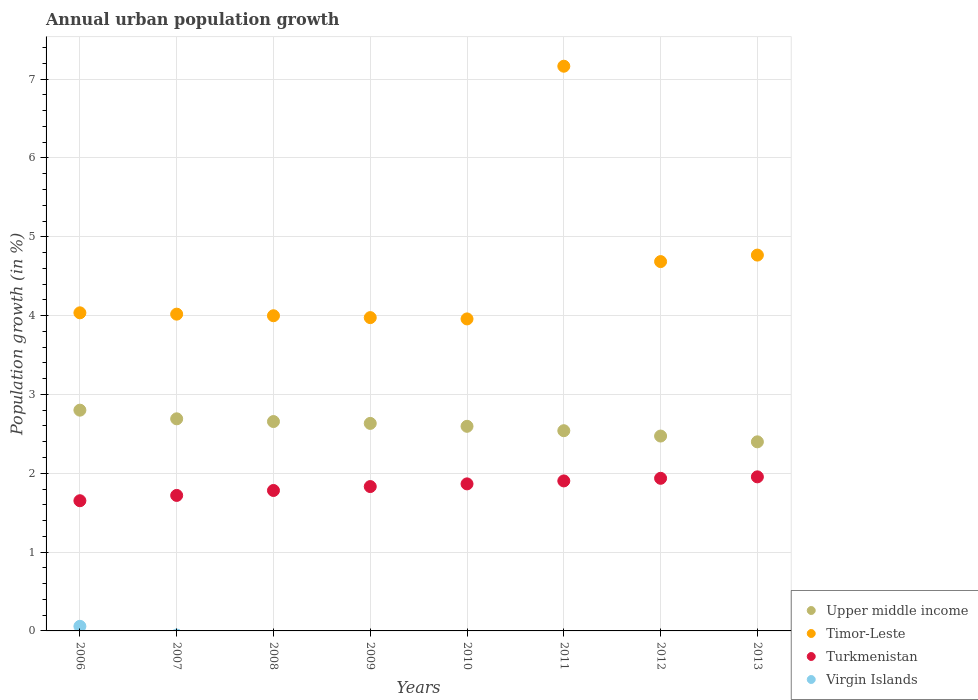How many different coloured dotlines are there?
Ensure brevity in your answer.  4. What is the percentage of urban population growth in Turkmenistan in 2007?
Make the answer very short. 1.72. Across all years, what is the maximum percentage of urban population growth in Upper middle income?
Make the answer very short. 2.8. Across all years, what is the minimum percentage of urban population growth in Upper middle income?
Your answer should be compact. 2.4. In which year was the percentage of urban population growth in Turkmenistan maximum?
Ensure brevity in your answer.  2013. What is the total percentage of urban population growth in Virgin Islands in the graph?
Your response must be concise. 0.06. What is the difference between the percentage of urban population growth in Timor-Leste in 2009 and that in 2011?
Give a very brief answer. -3.19. What is the difference between the percentage of urban population growth in Turkmenistan in 2006 and the percentage of urban population growth in Timor-Leste in 2007?
Your answer should be compact. -2.37. What is the average percentage of urban population growth in Timor-Leste per year?
Your response must be concise. 4.58. In the year 2008, what is the difference between the percentage of urban population growth in Upper middle income and percentage of urban population growth in Turkmenistan?
Your response must be concise. 0.87. What is the ratio of the percentage of urban population growth in Upper middle income in 2006 to that in 2010?
Offer a very short reply. 1.08. Is the percentage of urban population growth in Upper middle income in 2010 less than that in 2011?
Your response must be concise. No. What is the difference between the highest and the second highest percentage of urban population growth in Turkmenistan?
Give a very brief answer. 0.02. What is the difference between the highest and the lowest percentage of urban population growth in Virgin Islands?
Provide a succinct answer. 0.06. Is the sum of the percentage of urban population growth in Timor-Leste in 2006 and 2010 greater than the maximum percentage of urban population growth in Turkmenistan across all years?
Provide a short and direct response. Yes. Is it the case that in every year, the sum of the percentage of urban population growth in Upper middle income and percentage of urban population growth in Timor-Leste  is greater than the sum of percentage of urban population growth in Virgin Islands and percentage of urban population growth in Turkmenistan?
Your answer should be compact. Yes. Is it the case that in every year, the sum of the percentage of urban population growth in Turkmenistan and percentage of urban population growth in Virgin Islands  is greater than the percentage of urban population growth in Timor-Leste?
Offer a terse response. No. Does the percentage of urban population growth in Upper middle income monotonically increase over the years?
Your response must be concise. No. Is the percentage of urban population growth in Timor-Leste strictly less than the percentage of urban population growth in Upper middle income over the years?
Offer a terse response. No. How many dotlines are there?
Give a very brief answer. 4. Are the values on the major ticks of Y-axis written in scientific E-notation?
Make the answer very short. No. Does the graph contain any zero values?
Ensure brevity in your answer.  Yes. Does the graph contain grids?
Ensure brevity in your answer.  Yes. Where does the legend appear in the graph?
Your answer should be compact. Bottom right. How many legend labels are there?
Your answer should be very brief. 4. How are the legend labels stacked?
Provide a succinct answer. Vertical. What is the title of the graph?
Make the answer very short. Annual urban population growth. Does "Tanzania" appear as one of the legend labels in the graph?
Make the answer very short. No. What is the label or title of the X-axis?
Provide a short and direct response. Years. What is the label or title of the Y-axis?
Offer a terse response. Population growth (in %). What is the Population growth (in %) in Upper middle income in 2006?
Your response must be concise. 2.8. What is the Population growth (in %) in Timor-Leste in 2006?
Make the answer very short. 4.04. What is the Population growth (in %) of Turkmenistan in 2006?
Give a very brief answer. 1.65. What is the Population growth (in %) in Virgin Islands in 2006?
Offer a very short reply. 0.06. What is the Population growth (in %) of Upper middle income in 2007?
Make the answer very short. 2.69. What is the Population growth (in %) of Timor-Leste in 2007?
Give a very brief answer. 4.02. What is the Population growth (in %) in Turkmenistan in 2007?
Offer a terse response. 1.72. What is the Population growth (in %) in Virgin Islands in 2007?
Give a very brief answer. 0. What is the Population growth (in %) of Upper middle income in 2008?
Keep it short and to the point. 2.66. What is the Population growth (in %) of Timor-Leste in 2008?
Ensure brevity in your answer.  4. What is the Population growth (in %) of Turkmenistan in 2008?
Keep it short and to the point. 1.78. What is the Population growth (in %) in Virgin Islands in 2008?
Your answer should be compact. 0. What is the Population growth (in %) in Upper middle income in 2009?
Your response must be concise. 2.63. What is the Population growth (in %) of Timor-Leste in 2009?
Give a very brief answer. 3.97. What is the Population growth (in %) in Turkmenistan in 2009?
Provide a short and direct response. 1.83. What is the Population growth (in %) in Upper middle income in 2010?
Offer a terse response. 2.6. What is the Population growth (in %) of Timor-Leste in 2010?
Provide a succinct answer. 3.96. What is the Population growth (in %) in Turkmenistan in 2010?
Your answer should be very brief. 1.87. What is the Population growth (in %) in Upper middle income in 2011?
Provide a succinct answer. 2.54. What is the Population growth (in %) in Timor-Leste in 2011?
Offer a very short reply. 7.16. What is the Population growth (in %) of Turkmenistan in 2011?
Your answer should be compact. 1.9. What is the Population growth (in %) of Virgin Islands in 2011?
Keep it short and to the point. 0. What is the Population growth (in %) of Upper middle income in 2012?
Your answer should be very brief. 2.47. What is the Population growth (in %) in Timor-Leste in 2012?
Offer a very short reply. 4.69. What is the Population growth (in %) in Turkmenistan in 2012?
Your answer should be very brief. 1.94. What is the Population growth (in %) of Virgin Islands in 2012?
Offer a terse response. 0. What is the Population growth (in %) in Upper middle income in 2013?
Ensure brevity in your answer.  2.4. What is the Population growth (in %) of Timor-Leste in 2013?
Offer a terse response. 4.77. What is the Population growth (in %) in Turkmenistan in 2013?
Ensure brevity in your answer.  1.95. Across all years, what is the maximum Population growth (in %) in Upper middle income?
Offer a terse response. 2.8. Across all years, what is the maximum Population growth (in %) in Timor-Leste?
Provide a short and direct response. 7.16. Across all years, what is the maximum Population growth (in %) of Turkmenistan?
Give a very brief answer. 1.95. Across all years, what is the maximum Population growth (in %) of Virgin Islands?
Make the answer very short. 0.06. Across all years, what is the minimum Population growth (in %) in Upper middle income?
Provide a short and direct response. 2.4. Across all years, what is the minimum Population growth (in %) of Timor-Leste?
Give a very brief answer. 3.96. Across all years, what is the minimum Population growth (in %) in Turkmenistan?
Ensure brevity in your answer.  1.65. Across all years, what is the minimum Population growth (in %) of Virgin Islands?
Give a very brief answer. 0. What is the total Population growth (in %) in Upper middle income in the graph?
Ensure brevity in your answer.  20.79. What is the total Population growth (in %) in Timor-Leste in the graph?
Make the answer very short. 36.6. What is the total Population growth (in %) in Turkmenistan in the graph?
Offer a terse response. 14.64. What is the total Population growth (in %) in Virgin Islands in the graph?
Provide a short and direct response. 0.06. What is the difference between the Population growth (in %) of Upper middle income in 2006 and that in 2007?
Give a very brief answer. 0.11. What is the difference between the Population growth (in %) in Timor-Leste in 2006 and that in 2007?
Offer a terse response. 0.02. What is the difference between the Population growth (in %) of Turkmenistan in 2006 and that in 2007?
Offer a terse response. -0.07. What is the difference between the Population growth (in %) in Upper middle income in 2006 and that in 2008?
Your answer should be very brief. 0.14. What is the difference between the Population growth (in %) in Timor-Leste in 2006 and that in 2008?
Provide a short and direct response. 0.04. What is the difference between the Population growth (in %) of Turkmenistan in 2006 and that in 2008?
Give a very brief answer. -0.13. What is the difference between the Population growth (in %) in Upper middle income in 2006 and that in 2009?
Your answer should be compact. 0.17. What is the difference between the Population growth (in %) of Timor-Leste in 2006 and that in 2009?
Your answer should be very brief. 0.06. What is the difference between the Population growth (in %) of Turkmenistan in 2006 and that in 2009?
Provide a short and direct response. -0.18. What is the difference between the Population growth (in %) in Upper middle income in 2006 and that in 2010?
Your answer should be compact. 0.2. What is the difference between the Population growth (in %) of Timor-Leste in 2006 and that in 2010?
Offer a terse response. 0.08. What is the difference between the Population growth (in %) of Turkmenistan in 2006 and that in 2010?
Offer a very short reply. -0.21. What is the difference between the Population growth (in %) in Upper middle income in 2006 and that in 2011?
Ensure brevity in your answer.  0.26. What is the difference between the Population growth (in %) in Timor-Leste in 2006 and that in 2011?
Make the answer very short. -3.13. What is the difference between the Population growth (in %) in Turkmenistan in 2006 and that in 2011?
Make the answer very short. -0.25. What is the difference between the Population growth (in %) of Upper middle income in 2006 and that in 2012?
Provide a succinct answer. 0.33. What is the difference between the Population growth (in %) of Timor-Leste in 2006 and that in 2012?
Offer a very short reply. -0.65. What is the difference between the Population growth (in %) of Turkmenistan in 2006 and that in 2012?
Ensure brevity in your answer.  -0.28. What is the difference between the Population growth (in %) of Upper middle income in 2006 and that in 2013?
Offer a very short reply. 0.4. What is the difference between the Population growth (in %) in Timor-Leste in 2006 and that in 2013?
Keep it short and to the point. -0.73. What is the difference between the Population growth (in %) of Turkmenistan in 2006 and that in 2013?
Give a very brief answer. -0.3. What is the difference between the Population growth (in %) in Upper middle income in 2007 and that in 2008?
Your answer should be compact. 0.03. What is the difference between the Population growth (in %) of Timor-Leste in 2007 and that in 2008?
Keep it short and to the point. 0.02. What is the difference between the Population growth (in %) in Turkmenistan in 2007 and that in 2008?
Keep it short and to the point. -0.06. What is the difference between the Population growth (in %) in Upper middle income in 2007 and that in 2009?
Ensure brevity in your answer.  0.06. What is the difference between the Population growth (in %) in Timor-Leste in 2007 and that in 2009?
Provide a succinct answer. 0.04. What is the difference between the Population growth (in %) in Turkmenistan in 2007 and that in 2009?
Your answer should be compact. -0.11. What is the difference between the Population growth (in %) in Upper middle income in 2007 and that in 2010?
Make the answer very short. 0.1. What is the difference between the Population growth (in %) in Timor-Leste in 2007 and that in 2010?
Offer a terse response. 0.06. What is the difference between the Population growth (in %) in Turkmenistan in 2007 and that in 2010?
Give a very brief answer. -0.15. What is the difference between the Population growth (in %) in Upper middle income in 2007 and that in 2011?
Your answer should be very brief. 0.15. What is the difference between the Population growth (in %) in Timor-Leste in 2007 and that in 2011?
Provide a short and direct response. -3.15. What is the difference between the Population growth (in %) in Turkmenistan in 2007 and that in 2011?
Provide a short and direct response. -0.18. What is the difference between the Population growth (in %) in Upper middle income in 2007 and that in 2012?
Provide a succinct answer. 0.22. What is the difference between the Population growth (in %) of Timor-Leste in 2007 and that in 2012?
Give a very brief answer. -0.67. What is the difference between the Population growth (in %) in Turkmenistan in 2007 and that in 2012?
Your response must be concise. -0.22. What is the difference between the Population growth (in %) in Upper middle income in 2007 and that in 2013?
Your answer should be very brief. 0.29. What is the difference between the Population growth (in %) of Timor-Leste in 2007 and that in 2013?
Offer a terse response. -0.75. What is the difference between the Population growth (in %) in Turkmenistan in 2007 and that in 2013?
Keep it short and to the point. -0.24. What is the difference between the Population growth (in %) in Upper middle income in 2008 and that in 2009?
Offer a terse response. 0.02. What is the difference between the Population growth (in %) in Timor-Leste in 2008 and that in 2009?
Offer a terse response. 0.02. What is the difference between the Population growth (in %) of Turkmenistan in 2008 and that in 2009?
Provide a short and direct response. -0.05. What is the difference between the Population growth (in %) in Upper middle income in 2008 and that in 2010?
Offer a terse response. 0.06. What is the difference between the Population growth (in %) of Timor-Leste in 2008 and that in 2010?
Your response must be concise. 0.04. What is the difference between the Population growth (in %) of Turkmenistan in 2008 and that in 2010?
Ensure brevity in your answer.  -0.08. What is the difference between the Population growth (in %) of Upper middle income in 2008 and that in 2011?
Make the answer very short. 0.12. What is the difference between the Population growth (in %) of Timor-Leste in 2008 and that in 2011?
Offer a very short reply. -3.17. What is the difference between the Population growth (in %) of Turkmenistan in 2008 and that in 2011?
Make the answer very short. -0.12. What is the difference between the Population growth (in %) of Upper middle income in 2008 and that in 2012?
Make the answer very short. 0.18. What is the difference between the Population growth (in %) of Timor-Leste in 2008 and that in 2012?
Offer a terse response. -0.69. What is the difference between the Population growth (in %) in Turkmenistan in 2008 and that in 2012?
Give a very brief answer. -0.15. What is the difference between the Population growth (in %) of Upper middle income in 2008 and that in 2013?
Offer a very short reply. 0.26. What is the difference between the Population growth (in %) in Timor-Leste in 2008 and that in 2013?
Make the answer very short. -0.77. What is the difference between the Population growth (in %) in Turkmenistan in 2008 and that in 2013?
Your answer should be very brief. -0.17. What is the difference between the Population growth (in %) of Upper middle income in 2009 and that in 2010?
Your answer should be very brief. 0.04. What is the difference between the Population growth (in %) of Timor-Leste in 2009 and that in 2010?
Your answer should be very brief. 0.02. What is the difference between the Population growth (in %) in Turkmenistan in 2009 and that in 2010?
Provide a succinct answer. -0.03. What is the difference between the Population growth (in %) of Upper middle income in 2009 and that in 2011?
Provide a succinct answer. 0.09. What is the difference between the Population growth (in %) in Timor-Leste in 2009 and that in 2011?
Provide a succinct answer. -3.19. What is the difference between the Population growth (in %) of Turkmenistan in 2009 and that in 2011?
Your answer should be very brief. -0.07. What is the difference between the Population growth (in %) in Upper middle income in 2009 and that in 2012?
Offer a terse response. 0.16. What is the difference between the Population growth (in %) of Timor-Leste in 2009 and that in 2012?
Your answer should be very brief. -0.71. What is the difference between the Population growth (in %) of Turkmenistan in 2009 and that in 2012?
Make the answer very short. -0.1. What is the difference between the Population growth (in %) in Upper middle income in 2009 and that in 2013?
Keep it short and to the point. 0.23. What is the difference between the Population growth (in %) of Timor-Leste in 2009 and that in 2013?
Keep it short and to the point. -0.79. What is the difference between the Population growth (in %) of Turkmenistan in 2009 and that in 2013?
Give a very brief answer. -0.12. What is the difference between the Population growth (in %) of Upper middle income in 2010 and that in 2011?
Offer a very short reply. 0.06. What is the difference between the Population growth (in %) in Timor-Leste in 2010 and that in 2011?
Provide a short and direct response. -3.21. What is the difference between the Population growth (in %) of Turkmenistan in 2010 and that in 2011?
Your answer should be compact. -0.04. What is the difference between the Population growth (in %) in Upper middle income in 2010 and that in 2012?
Offer a very short reply. 0.12. What is the difference between the Population growth (in %) in Timor-Leste in 2010 and that in 2012?
Your response must be concise. -0.73. What is the difference between the Population growth (in %) of Turkmenistan in 2010 and that in 2012?
Your answer should be very brief. -0.07. What is the difference between the Population growth (in %) in Upper middle income in 2010 and that in 2013?
Give a very brief answer. 0.2. What is the difference between the Population growth (in %) in Timor-Leste in 2010 and that in 2013?
Offer a very short reply. -0.81. What is the difference between the Population growth (in %) of Turkmenistan in 2010 and that in 2013?
Your answer should be very brief. -0.09. What is the difference between the Population growth (in %) in Upper middle income in 2011 and that in 2012?
Provide a short and direct response. 0.07. What is the difference between the Population growth (in %) of Timor-Leste in 2011 and that in 2012?
Your answer should be compact. 2.48. What is the difference between the Population growth (in %) of Turkmenistan in 2011 and that in 2012?
Your answer should be compact. -0.03. What is the difference between the Population growth (in %) of Upper middle income in 2011 and that in 2013?
Offer a terse response. 0.14. What is the difference between the Population growth (in %) of Timor-Leste in 2011 and that in 2013?
Your answer should be very brief. 2.4. What is the difference between the Population growth (in %) in Turkmenistan in 2011 and that in 2013?
Make the answer very short. -0.05. What is the difference between the Population growth (in %) of Upper middle income in 2012 and that in 2013?
Give a very brief answer. 0.07. What is the difference between the Population growth (in %) in Timor-Leste in 2012 and that in 2013?
Provide a short and direct response. -0.08. What is the difference between the Population growth (in %) in Turkmenistan in 2012 and that in 2013?
Keep it short and to the point. -0.02. What is the difference between the Population growth (in %) in Upper middle income in 2006 and the Population growth (in %) in Timor-Leste in 2007?
Give a very brief answer. -1.22. What is the difference between the Population growth (in %) in Upper middle income in 2006 and the Population growth (in %) in Turkmenistan in 2007?
Offer a terse response. 1.08. What is the difference between the Population growth (in %) of Timor-Leste in 2006 and the Population growth (in %) of Turkmenistan in 2007?
Offer a very short reply. 2.32. What is the difference between the Population growth (in %) of Upper middle income in 2006 and the Population growth (in %) of Timor-Leste in 2008?
Keep it short and to the point. -1.2. What is the difference between the Population growth (in %) of Upper middle income in 2006 and the Population growth (in %) of Turkmenistan in 2008?
Provide a succinct answer. 1.02. What is the difference between the Population growth (in %) in Timor-Leste in 2006 and the Population growth (in %) in Turkmenistan in 2008?
Your response must be concise. 2.25. What is the difference between the Population growth (in %) in Upper middle income in 2006 and the Population growth (in %) in Timor-Leste in 2009?
Keep it short and to the point. -1.17. What is the difference between the Population growth (in %) in Upper middle income in 2006 and the Population growth (in %) in Turkmenistan in 2009?
Provide a short and direct response. 0.97. What is the difference between the Population growth (in %) in Timor-Leste in 2006 and the Population growth (in %) in Turkmenistan in 2009?
Keep it short and to the point. 2.2. What is the difference between the Population growth (in %) of Upper middle income in 2006 and the Population growth (in %) of Timor-Leste in 2010?
Offer a terse response. -1.16. What is the difference between the Population growth (in %) in Upper middle income in 2006 and the Population growth (in %) in Turkmenistan in 2010?
Offer a very short reply. 0.94. What is the difference between the Population growth (in %) in Timor-Leste in 2006 and the Population growth (in %) in Turkmenistan in 2010?
Your response must be concise. 2.17. What is the difference between the Population growth (in %) of Upper middle income in 2006 and the Population growth (in %) of Timor-Leste in 2011?
Offer a very short reply. -4.36. What is the difference between the Population growth (in %) in Upper middle income in 2006 and the Population growth (in %) in Turkmenistan in 2011?
Your response must be concise. 0.9. What is the difference between the Population growth (in %) in Timor-Leste in 2006 and the Population growth (in %) in Turkmenistan in 2011?
Your response must be concise. 2.13. What is the difference between the Population growth (in %) of Upper middle income in 2006 and the Population growth (in %) of Timor-Leste in 2012?
Give a very brief answer. -1.88. What is the difference between the Population growth (in %) of Upper middle income in 2006 and the Population growth (in %) of Turkmenistan in 2012?
Your answer should be compact. 0.86. What is the difference between the Population growth (in %) in Timor-Leste in 2006 and the Population growth (in %) in Turkmenistan in 2012?
Offer a terse response. 2.1. What is the difference between the Population growth (in %) of Upper middle income in 2006 and the Population growth (in %) of Timor-Leste in 2013?
Your response must be concise. -1.97. What is the difference between the Population growth (in %) of Upper middle income in 2006 and the Population growth (in %) of Turkmenistan in 2013?
Your response must be concise. 0.85. What is the difference between the Population growth (in %) of Timor-Leste in 2006 and the Population growth (in %) of Turkmenistan in 2013?
Provide a short and direct response. 2.08. What is the difference between the Population growth (in %) of Upper middle income in 2007 and the Population growth (in %) of Timor-Leste in 2008?
Your answer should be very brief. -1.31. What is the difference between the Population growth (in %) of Timor-Leste in 2007 and the Population growth (in %) of Turkmenistan in 2008?
Provide a short and direct response. 2.24. What is the difference between the Population growth (in %) in Upper middle income in 2007 and the Population growth (in %) in Timor-Leste in 2009?
Your answer should be very brief. -1.28. What is the difference between the Population growth (in %) in Upper middle income in 2007 and the Population growth (in %) in Turkmenistan in 2009?
Your answer should be compact. 0.86. What is the difference between the Population growth (in %) of Timor-Leste in 2007 and the Population growth (in %) of Turkmenistan in 2009?
Give a very brief answer. 2.19. What is the difference between the Population growth (in %) of Upper middle income in 2007 and the Population growth (in %) of Timor-Leste in 2010?
Keep it short and to the point. -1.27. What is the difference between the Population growth (in %) of Upper middle income in 2007 and the Population growth (in %) of Turkmenistan in 2010?
Your response must be concise. 0.83. What is the difference between the Population growth (in %) in Timor-Leste in 2007 and the Population growth (in %) in Turkmenistan in 2010?
Your answer should be compact. 2.15. What is the difference between the Population growth (in %) in Upper middle income in 2007 and the Population growth (in %) in Timor-Leste in 2011?
Your answer should be very brief. -4.47. What is the difference between the Population growth (in %) of Upper middle income in 2007 and the Population growth (in %) of Turkmenistan in 2011?
Provide a succinct answer. 0.79. What is the difference between the Population growth (in %) in Timor-Leste in 2007 and the Population growth (in %) in Turkmenistan in 2011?
Provide a succinct answer. 2.12. What is the difference between the Population growth (in %) in Upper middle income in 2007 and the Population growth (in %) in Timor-Leste in 2012?
Your answer should be compact. -1.99. What is the difference between the Population growth (in %) of Upper middle income in 2007 and the Population growth (in %) of Turkmenistan in 2012?
Keep it short and to the point. 0.75. What is the difference between the Population growth (in %) of Timor-Leste in 2007 and the Population growth (in %) of Turkmenistan in 2012?
Offer a terse response. 2.08. What is the difference between the Population growth (in %) of Upper middle income in 2007 and the Population growth (in %) of Timor-Leste in 2013?
Provide a short and direct response. -2.08. What is the difference between the Population growth (in %) of Upper middle income in 2007 and the Population growth (in %) of Turkmenistan in 2013?
Your answer should be very brief. 0.74. What is the difference between the Population growth (in %) in Timor-Leste in 2007 and the Population growth (in %) in Turkmenistan in 2013?
Give a very brief answer. 2.06. What is the difference between the Population growth (in %) of Upper middle income in 2008 and the Population growth (in %) of Timor-Leste in 2009?
Offer a terse response. -1.32. What is the difference between the Population growth (in %) in Upper middle income in 2008 and the Population growth (in %) in Turkmenistan in 2009?
Your answer should be compact. 0.82. What is the difference between the Population growth (in %) in Timor-Leste in 2008 and the Population growth (in %) in Turkmenistan in 2009?
Ensure brevity in your answer.  2.17. What is the difference between the Population growth (in %) of Upper middle income in 2008 and the Population growth (in %) of Timor-Leste in 2010?
Your answer should be very brief. -1.3. What is the difference between the Population growth (in %) of Upper middle income in 2008 and the Population growth (in %) of Turkmenistan in 2010?
Your answer should be very brief. 0.79. What is the difference between the Population growth (in %) in Timor-Leste in 2008 and the Population growth (in %) in Turkmenistan in 2010?
Offer a very short reply. 2.13. What is the difference between the Population growth (in %) of Upper middle income in 2008 and the Population growth (in %) of Timor-Leste in 2011?
Give a very brief answer. -4.51. What is the difference between the Population growth (in %) in Upper middle income in 2008 and the Population growth (in %) in Turkmenistan in 2011?
Your answer should be compact. 0.75. What is the difference between the Population growth (in %) in Timor-Leste in 2008 and the Population growth (in %) in Turkmenistan in 2011?
Keep it short and to the point. 2.1. What is the difference between the Population growth (in %) in Upper middle income in 2008 and the Population growth (in %) in Timor-Leste in 2012?
Offer a very short reply. -2.03. What is the difference between the Population growth (in %) of Upper middle income in 2008 and the Population growth (in %) of Turkmenistan in 2012?
Offer a very short reply. 0.72. What is the difference between the Population growth (in %) of Timor-Leste in 2008 and the Population growth (in %) of Turkmenistan in 2012?
Your answer should be compact. 2.06. What is the difference between the Population growth (in %) in Upper middle income in 2008 and the Population growth (in %) in Timor-Leste in 2013?
Keep it short and to the point. -2.11. What is the difference between the Population growth (in %) of Upper middle income in 2008 and the Population growth (in %) of Turkmenistan in 2013?
Ensure brevity in your answer.  0.7. What is the difference between the Population growth (in %) of Timor-Leste in 2008 and the Population growth (in %) of Turkmenistan in 2013?
Keep it short and to the point. 2.04. What is the difference between the Population growth (in %) in Upper middle income in 2009 and the Population growth (in %) in Timor-Leste in 2010?
Ensure brevity in your answer.  -1.33. What is the difference between the Population growth (in %) of Upper middle income in 2009 and the Population growth (in %) of Turkmenistan in 2010?
Your response must be concise. 0.77. What is the difference between the Population growth (in %) of Timor-Leste in 2009 and the Population growth (in %) of Turkmenistan in 2010?
Make the answer very short. 2.11. What is the difference between the Population growth (in %) of Upper middle income in 2009 and the Population growth (in %) of Timor-Leste in 2011?
Offer a very short reply. -4.53. What is the difference between the Population growth (in %) in Upper middle income in 2009 and the Population growth (in %) in Turkmenistan in 2011?
Provide a succinct answer. 0.73. What is the difference between the Population growth (in %) in Timor-Leste in 2009 and the Population growth (in %) in Turkmenistan in 2011?
Offer a terse response. 2.07. What is the difference between the Population growth (in %) of Upper middle income in 2009 and the Population growth (in %) of Timor-Leste in 2012?
Your answer should be very brief. -2.05. What is the difference between the Population growth (in %) of Upper middle income in 2009 and the Population growth (in %) of Turkmenistan in 2012?
Offer a terse response. 0.7. What is the difference between the Population growth (in %) in Timor-Leste in 2009 and the Population growth (in %) in Turkmenistan in 2012?
Your response must be concise. 2.04. What is the difference between the Population growth (in %) of Upper middle income in 2009 and the Population growth (in %) of Timor-Leste in 2013?
Keep it short and to the point. -2.14. What is the difference between the Population growth (in %) of Upper middle income in 2009 and the Population growth (in %) of Turkmenistan in 2013?
Your response must be concise. 0.68. What is the difference between the Population growth (in %) of Timor-Leste in 2009 and the Population growth (in %) of Turkmenistan in 2013?
Offer a very short reply. 2.02. What is the difference between the Population growth (in %) of Upper middle income in 2010 and the Population growth (in %) of Timor-Leste in 2011?
Give a very brief answer. -4.57. What is the difference between the Population growth (in %) of Upper middle income in 2010 and the Population growth (in %) of Turkmenistan in 2011?
Your answer should be compact. 0.69. What is the difference between the Population growth (in %) in Timor-Leste in 2010 and the Population growth (in %) in Turkmenistan in 2011?
Provide a short and direct response. 2.06. What is the difference between the Population growth (in %) of Upper middle income in 2010 and the Population growth (in %) of Timor-Leste in 2012?
Your answer should be compact. -2.09. What is the difference between the Population growth (in %) in Upper middle income in 2010 and the Population growth (in %) in Turkmenistan in 2012?
Your answer should be very brief. 0.66. What is the difference between the Population growth (in %) in Timor-Leste in 2010 and the Population growth (in %) in Turkmenistan in 2012?
Ensure brevity in your answer.  2.02. What is the difference between the Population growth (in %) of Upper middle income in 2010 and the Population growth (in %) of Timor-Leste in 2013?
Provide a short and direct response. -2.17. What is the difference between the Population growth (in %) of Upper middle income in 2010 and the Population growth (in %) of Turkmenistan in 2013?
Your answer should be very brief. 0.64. What is the difference between the Population growth (in %) in Timor-Leste in 2010 and the Population growth (in %) in Turkmenistan in 2013?
Offer a very short reply. 2. What is the difference between the Population growth (in %) in Upper middle income in 2011 and the Population growth (in %) in Timor-Leste in 2012?
Your answer should be compact. -2.15. What is the difference between the Population growth (in %) in Upper middle income in 2011 and the Population growth (in %) in Turkmenistan in 2012?
Your response must be concise. 0.6. What is the difference between the Population growth (in %) of Timor-Leste in 2011 and the Population growth (in %) of Turkmenistan in 2012?
Your answer should be compact. 5.23. What is the difference between the Population growth (in %) of Upper middle income in 2011 and the Population growth (in %) of Timor-Leste in 2013?
Offer a terse response. -2.23. What is the difference between the Population growth (in %) in Upper middle income in 2011 and the Population growth (in %) in Turkmenistan in 2013?
Keep it short and to the point. 0.59. What is the difference between the Population growth (in %) in Timor-Leste in 2011 and the Population growth (in %) in Turkmenistan in 2013?
Your answer should be compact. 5.21. What is the difference between the Population growth (in %) of Upper middle income in 2012 and the Population growth (in %) of Timor-Leste in 2013?
Offer a very short reply. -2.3. What is the difference between the Population growth (in %) of Upper middle income in 2012 and the Population growth (in %) of Turkmenistan in 2013?
Your answer should be very brief. 0.52. What is the difference between the Population growth (in %) of Timor-Leste in 2012 and the Population growth (in %) of Turkmenistan in 2013?
Offer a terse response. 2.73. What is the average Population growth (in %) of Upper middle income per year?
Offer a very short reply. 2.6. What is the average Population growth (in %) of Timor-Leste per year?
Offer a terse response. 4.58. What is the average Population growth (in %) of Turkmenistan per year?
Ensure brevity in your answer.  1.83. What is the average Population growth (in %) of Virgin Islands per year?
Provide a succinct answer. 0.01. In the year 2006, what is the difference between the Population growth (in %) of Upper middle income and Population growth (in %) of Timor-Leste?
Your answer should be compact. -1.23. In the year 2006, what is the difference between the Population growth (in %) in Upper middle income and Population growth (in %) in Turkmenistan?
Provide a succinct answer. 1.15. In the year 2006, what is the difference between the Population growth (in %) in Upper middle income and Population growth (in %) in Virgin Islands?
Offer a terse response. 2.74. In the year 2006, what is the difference between the Population growth (in %) of Timor-Leste and Population growth (in %) of Turkmenistan?
Offer a very short reply. 2.38. In the year 2006, what is the difference between the Population growth (in %) of Timor-Leste and Population growth (in %) of Virgin Islands?
Offer a very short reply. 3.98. In the year 2006, what is the difference between the Population growth (in %) in Turkmenistan and Population growth (in %) in Virgin Islands?
Provide a succinct answer. 1.59. In the year 2007, what is the difference between the Population growth (in %) in Upper middle income and Population growth (in %) in Timor-Leste?
Provide a succinct answer. -1.33. In the year 2007, what is the difference between the Population growth (in %) of Upper middle income and Population growth (in %) of Turkmenistan?
Offer a terse response. 0.97. In the year 2007, what is the difference between the Population growth (in %) in Timor-Leste and Population growth (in %) in Turkmenistan?
Give a very brief answer. 2.3. In the year 2008, what is the difference between the Population growth (in %) of Upper middle income and Population growth (in %) of Timor-Leste?
Offer a very short reply. -1.34. In the year 2008, what is the difference between the Population growth (in %) in Upper middle income and Population growth (in %) in Turkmenistan?
Provide a short and direct response. 0.87. In the year 2008, what is the difference between the Population growth (in %) of Timor-Leste and Population growth (in %) of Turkmenistan?
Your answer should be very brief. 2.22. In the year 2009, what is the difference between the Population growth (in %) in Upper middle income and Population growth (in %) in Timor-Leste?
Offer a terse response. -1.34. In the year 2009, what is the difference between the Population growth (in %) in Upper middle income and Population growth (in %) in Turkmenistan?
Ensure brevity in your answer.  0.8. In the year 2009, what is the difference between the Population growth (in %) of Timor-Leste and Population growth (in %) of Turkmenistan?
Make the answer very short. 2.14. In the year 2010, what is the difference between the Population growth (in %) of Upper middle income and Population growth (in %) of Timor-Leste?
Your answer should be compact. -1.36. In the year 2010, what is the difference between the Population growth (in %) in Upper middle income and Population growth (in %) in Turkmenistan?
Your answer should be compact. 0.73. In the year 2010, what is the difference between the Population growth (in %) of Timor-Leste and Population growth (in %) of Turkmenistan?
Provide a succinct answer. 2.09. In the year 2011, what is the difference between the Population growth (in %) in Upper middle income and Population growth (in %) in Timor-Leste?
Your response must be concise. -4.62. In the year 2011, what is the difference between the Population growth (in %) in Upper middle income and Population growth (in %) in Turkmenistan?
Keep it short and to the point. 0.64. In the year 2011, what is the difference between the Population growth (in %) in Timor-Leste and Population growth (in %) in Turkmenistan?
Your answer should be compact. 5.26. In the year 2012, what is the difference between the Population growth (in %) in Upper middle income and Population growth (in %) in Timor-Leste?
Ensure brevity in your answer.  -2.21. In the year 2012, what is the difference between the Population growth (in %) of Upper middle income and Population growth (in %) of Turkmenistan?
Your response must be concise. 0.54. In the year 2012, what is the difference between the Population growth (in %) of Timor-Leste and Population growth (in %) of Turkmenistan?
Provide a succinct answer. 2.75. In the year 2013, what is the difference between the Population growth (in %) of Upper middle income and Population growth (in %) of Timor-Leste?
Your answer should be compact. -2.37. In the year 2013, what is the difference between the Population growth (in %) in Upper middle income and Population growth (in %) in Turkmenistan?
Your answer should be very brief. 0.44. In the year 2013, what is the difference between the Population growth (in %) of Timor-Leste and Population growth (in %) of Turkmenistan?
Your response must be concise. 2.81. What is the ratio of the Population growth (in %) of Upper middle income in 2006 to that in 2007?
Make the answer very short. 1.04. What is the ratio of the Population growth (in %) in Turkmenistan in 2006 to that in 2007?
Provide a short and direct response. 0.96. What is the ratio of the Population growth (in %) of Upper middle income in 2006 to that in 2008?
Your response must be concise. 1.05. What is the ratio of the Population growth (in %) in Timor-Leste in 2006 to that in 2008?
Provide a succinct answer. 1.01. What is the ratio of the Population growth (in %) in Turkmenistan in 2006 to that in 2008?
Offer a very short reply. 0.93. What is the ratio of the Population growth (in %) in Upper middle income in 2006 to that in 2009?
Offer a very short reply. 1.06. What is the ratio of the Population growth (in %) of Timor-Leste in 2006 to that in 2009?
Provide a short and direct response. 1.02. What is the ratio of the Population growth (in %) in Turkmenistan in 2006 to that in 2009?
Your answer should be very brief. 0.9. What is the ratio of the Population growth (in %) in Upper middle income in 2006 to that in 2010?
Keep it short and to the point. 1.08. What is the ratio of the Population growth (in %) in Timor-Leste in 2006 to that in 2010?
Your answer should be compact. 1.02. What is the ratio of the Population growth (in %) of Turkmenistan in 2006 to that in 2010?
Offer a terse response. 0.89. What is the ratio of the Population growth (in %) in Upper middle income in 2006 to that in 2011?
Ensure brevity in your answer.  1.1. What is the ratio of the Population growth (in %) of Timor-Leste in 2006 to that in 2011?
Provide a short and direct response. 0.56. What is the ratio of the Population growth (in %) in Turkmenistan in 2006 to that in 2011?
Ensure brevity in your answer.  0.87. What is the ratio of the Population growth (in %) of Upper middle income in 2006 to that in 2012?
Your answer should be very brief. 1.13. What is the ratio of the Population growth (in %) in Timor-Leste in 2006 to that in 2012?
Keep it short and to the point. 0.86. What is the ratio of the Population growth (in %) in Turkmenistan in 2006 to that in 2012?
Your answer should be compact. 0.85. What is the ratio of the Population growth (in %) in Upper middle income in 2006 to that in 2013?
Provide a succinct answer. 1.17. What is the ratio of the Population growth (in %) of Timor-Leste in 2006 to that in 2013?
Keep it short and to the point. 0.85. What is the ratio of the Population growth (in %) of Turkmenistan in 2006 to that in 2013?
Keep it short and to the point. 0.84. What is the ratio of the Population growth (in %) in Upper middle income in 2007 to that in 2008?
Provide a short and direct response. 1.01. What is the ratio of the Population growth (in %) of Timor-Leste in 2007 to that in 2008?
Make the answer very short. 1.01. What is the ratio of the Population growth (in %) of Turkmenistan in 2007 to that in 2008?
Your answer should be compact. 0.96. What is the ratio of the Population growth (in %) of Upper middle income in 2007 to that in 2009?
Your answer should be compact. 1.02. What is the ratio of the Population growth (in %) of Timor-Leste in 2007 to that in 2009?
Provide a short and direct response. 1.01. What is the ratio of the Population growth (in %) in Turkmenistan in 2007 to that in 2009?
Provide a short and direct response. 0.94. What is the ratio of the Population growth (in %) in Upper middle income in 2007 to that in 2010?
Offer a very short reply. 1.04. What is the ratio of the Population growth (in %) of Timor-Leste in 2007 to that in 2010?
Your answer should be compact. 1.02. What is the ratio of the Population growth (in %) of Turkmenistan in 2007 to that in 2010?
Make the answer very short. 0.92. What is the ratio of the Population growth (in %) of Upper middle income in 2007 to that in 2011?
Provide a short and direct response. 1.06. What is the ratio of the Population growth (in %) of Timor-Leste in 2007 to that in 2011?
Offer a very short reply. 0.56. What is the ratio of the Population growth (in %) of Turkmenistan in 2007 to that in 2011?
Ensure brevity in your answer.  0.9. What is the ratio of the Population growth (in %) in Upper middle income in 2007 to that in 2012?
Provide a short and direct response. 1.09. What is the ratio of the Population growth (in %) in Timor-Leste in 2007 to that in 2012?
Keep it short and to the point. 0.86. What is the ratio of the Population growth (in %) in Turkmenistan in 2007 to that in 2012?
Keep it short and to the point. 0.89. What is the ratio of the Population growth (in %) of Upper middle income in 2007 to that in 2013?
Your answer should be compact. 1.12. What is the ratio of the Population growth (in %) in Timor-Leste in 2007 to that in 2013?
Your answer should be compact. 0.84. What is the ratio of the Population growth (in %) of Turkmenistan in 2007 to that in 2013?
Your response must be concise. 0.88. What is the ratio of the Population growth (in %) of Upper middle income in 2008 to that in 2009?
Offer a terse response. 1.01. What is the ratio of the Population growth (in %) of Turkmenistan in 2008 to that in 2009?
Offer a very short reply. 0.97. What is the ratio of the Population growth (in %) in Upper middle income in 2008 to that in 2010?
Your answer should be compact. 1.02. What is the ratio of the Population growth (in %) of Timor-Leste in 2008 to that in 2010?
Offer a terse response. 1.01. What is the ratio of the Population growth (in %) of Turkmenistan in 2008 to that in 2010?
Offer a terse response. 0.96. What is the ratio of the Population growth (in %) in Upper middle income in 2008 to that in 2011?
Provide a succinct answer. 1.05. What is the ratio of the Population growth (in %) of Timor-Leste in 2008 to that in 2011?
Provide a succinct answer. 0.56. What is the ratio of the Population growth (in %) of Turkmenistan in 2008 to that in 2011?
Give a very brief answer. 0.94. What is the ratio of the Population growth (in %) of Upper middle income in 2008 to that in 2012?
Provide a short and direct response. 1.07. What is the ratio of the Population growth (in %) in Timor-Leste in 2008 to that in 2012?
Provide a short and direct response. 0.85. What is the ratio of the Population growth (in %) in Turkmenistan in 2008 to that in 2012?
Your answer should be very brief. 0.92. What is the ratio of the Population growth (in %) of Upper middle income in 2008 to that in 2013?
Your answer should be very brief. 1.11. What is the ratio of the Population growth (in %) of Timor-Leste in 2008 to that in 2013?
Your answer should be compact. 0.84. What is the ratio of the Population growth (in %) of Turkmenistan in 2008 to that in 2013?
Ensure brevity in your answer.  0.91. What is the ratio of the Population growth (in %) in Upper middle income in 2009 to that in 2010?
Make the answer very short. 1.01. What is the ratio of the Population growth (in %) in Timor-Leste in 2009 to that in 2010?
Make the answer very short. 1. What is the ratio of the Population growth (in %) in Turkmenistan in 2009 to that in 2010?
Make the answer very short. 0.98. What is the ratio of the Population growth (in %) of Upper middle income in 2009 to that in 2011?
Your answer should be very brief. 1.04. What is the ratio of the Population growth (in %) of Timor-Leste in 2009 to that in 2011?
Your answer should be compact. 0.55. What is the ratio of the Population growth (in %) of Turkmenistan in 2009 to that in 2011?
Offer a very short reply. 0.96. What is the ratio of the Population growth (in %) in Upper middle income in 2009 to that in 2012?
Make the answer very short. 1.06. What is the ratio of the Population growth (in %) in Timor-Leste in 2009 to that in 2012?
Ensure brevity in your answer.  0.85. What is the ratio of the Population growth (in %) of Turkmenistan in 2009 to that in 2012?
Keep it short and to the point. 0.95. What is the ratio of the Population growth (in %) in Upper middle income in 2009 to that in 2013?
Provide a succinct answer. 1.1. What is the ratio of the Population growth (in %) of Timor-Leste in 2009 to that in 2013?
Give a very brief answer. 0.83. What is the ratio of the Population growth (in %) of Turkmenistan in 2009 to that in 2013?
Provide a succinct answer. 0.94. What is the ratio of the Population growth (in %) of Timor-Leste in 2010 to that in 2011?
Your response must be concise. 0.55. What is the ratio of the Population growth (in %) of Turkmenistan in 2010 to that in 2011?
Give a very brief answer. 0.98. What is the ratio of the Population growth (in %) of Timor-Leste in 2010 to that in 2012?
Your answer should be compact. 0.84. What is the ratio of the Population growth (in %) in Turkmenistan in 2010 to that in 2012?
Ensure brevity in your answer.  0.96. What is the ratio of the Population growth (in %) of Upper middle income in 2010 to that in 2013?
Provide a short and direct response. 1.08. What is the ratio of the Population growth (in %) in Timor-Leste in 2010 to that in 2013?
Ensure brevity in your answer.  0.83. What is the ratio of the Population growth (in %) in Turkmenistan in 2010 to that in 2013?
Make the answer very short. 0.95. What is the ratio of the Population growth (in %) in Upper middle income in 2011 to that in 2012?
Your answer should be very brief. 1.03. What is the ratio of the Population growth (in %) in Timor-Leste in 2011 to that in 2012?
Make the answer very short. 1.53. What is the ratio of the Population growth (in %) in Turkmenistan in 2011 to that in 2012?
Give a very brief answer. 0.98. What is the ratio of the Population growth (in %) in Upper middle income in 2011 to that in 2013?
Give a very brief answer. 1.06. What is the ratio of the Population growth (in %) of Timor-Leste in 2011 to that in 2013?
Make the answer very short. 1.5. What is the ratio of the Population growth (in %) in Turkmenistan in 2011 to that in 2013?
Keep it short and to the point. 0.97. What is the ratio of the Population growth (in %) of Upper middle income in 2012 to that in 2013?
Your answer should be very brief. 1.03. What is the ratio of the Population growth (in %) of Timor-Leste in 2012 to that in 2013?
Offer a terse response. 0.98. What is the ratio of the Population growth (in %) of Turkmenistan in 2012 to that in 2013?
Your answer should be compact. 0.99. What is the difference between the highest and the second highest Population growth (in %) of Upper middle income?
Ensure brevity in your answer.  0.11. What is the difference between the highest and the second highest Population growth (in %) in Timor-Leste?
Give a very brief answer. 2.4. What is the difference between the highest and the second highest Population growth (in %) of Turkmenistan?
Keep it short and to the point. 0.02. What is the difference between the highest and the lowest Population growth (in %) in Upper middle income?
Provide a succinct answer. 0.4. What is the difference between the highest and the lowest Population growth (in %) of Timor-Leste?
Give a very brief answer. 3.21. What is the difference between the highest and the lowest Population growth (in %) in Turkmenistan?
Provide a succinct answer. 0.3. What is the difference between the highest and the lowest Population growth (in %) in Virgin Islands?
Provide a short and direct response. 0.06. 